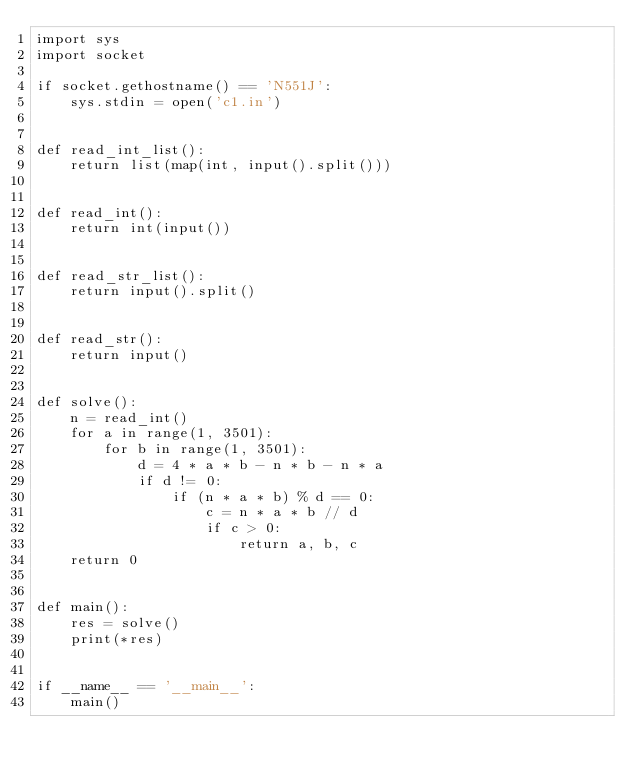Convert code to text. <code><loc_0><loc_0><loc_500><loc_500><_Python_>import sys
import socket

if socket.gethostname() == 'N551J':
    sys.stdin = open('c1.in')


def read_int_list():
    return list(map(int, input().split()))


def read_int():
    return int(input())


def read_str_list():
    return input().split()


def read_str():
    return input()


def solve():
    n = read_int()
    for a in range(1, 3501):
        for b in range(1, 3501):
            d = 4 * a * b - n * b - n * a
            if d != 0:
                if (n * a * b) % d == 0:
                    c = n * a * b // d
                    if c > 0:
                        return a, b, c
    return 0


def main():
    res = solve()
    print(*res)


if __name__ == '__main__':
    main()
</code> 